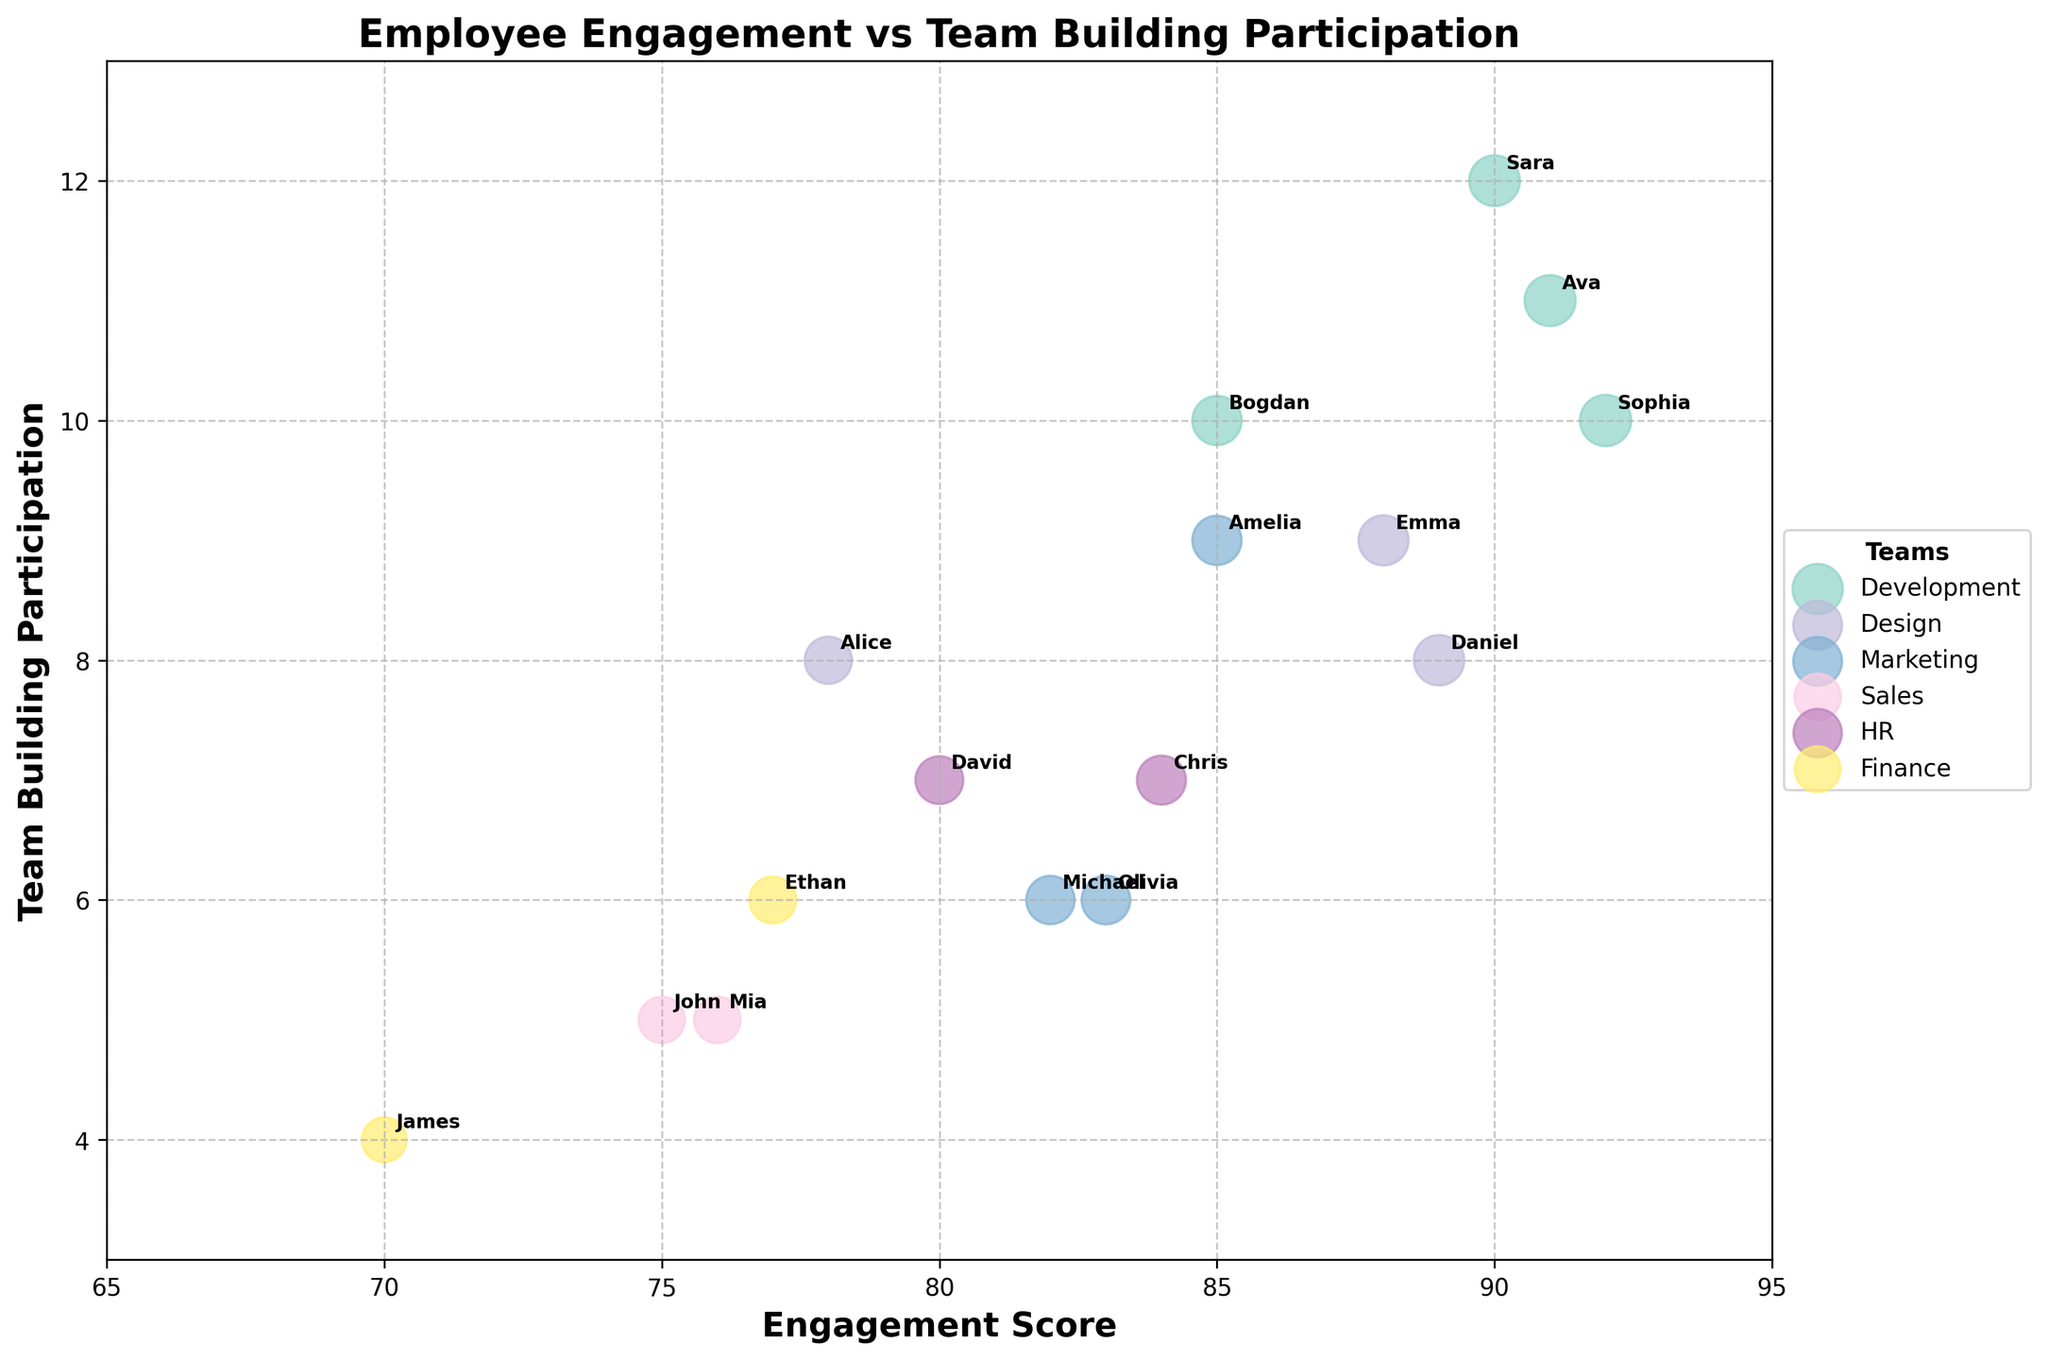What’s the title of the figure? The title of the figure is written at the top and is bolded.
Answer: Employee Engagement vs Team Building Participation What are the labels on the axes? The labels on the x-axis and the y-axis are found running along the respective axes and are bold.
Answer: Engagement Score (x-axis) and Team Building Participation (y-axis) How many data points represent employees in the Design team? Data points for each team are plotted in different colors, and there's also a legend indicating the team.
Answer: 3 Which employee from the Development team has the highest engagement score? By looking at the points for the Development team and comparing their Engagement Scores, we can find the employee with the highest score.
Answer: Sophia What is the range of participation in team-building activities for employees from the Marketing team? The participation data points for Marketing are visible on the y-axis; the range is found between the minimum and maximum values.
Answer: 6 to 9 How does Sara's participation in team-building activities compare with Bogdan's? Both Sara and Bogdan are labeled on the chart; we can compare the y-axis values of their respective points.
Answer: Sara has higher participation What's the average engagement score for employees in the HR team? Locate the data points for HR on the chart. The Engagement Scores are 80 and 84; their average is calculated by summing them and dividing by the count.
Answer: 82 (80 + 84) / 2 = 82 Which team has the widest range of engagement scores? Compare the range between the highest and lowest engagement scores within each team.
Answer: Development (85 - 92) Compare the engagement scores of employees from Sales with those from Finance. Which group has a higher average? Identify and average the Engagement Scores for each team. For Sales: (75 + 76) / 2 = 75.5, and for Finance: (70 + 77) / 2 = 73.5. Compare these averages.
Answer: Sales 